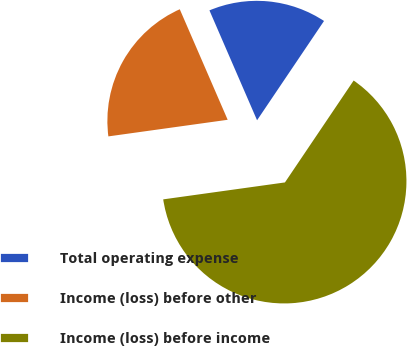Convert chart to OTSL. <chart><loc_0><loc_0><loc_500><loc_500><pie_chart><fcel>Total operating expense<fcel>Income (loss) before other<fcel>Income (loss) before income<nl><fcel>15.95%<fcel>20.69%<fcel>63.35%<nl></chart> 